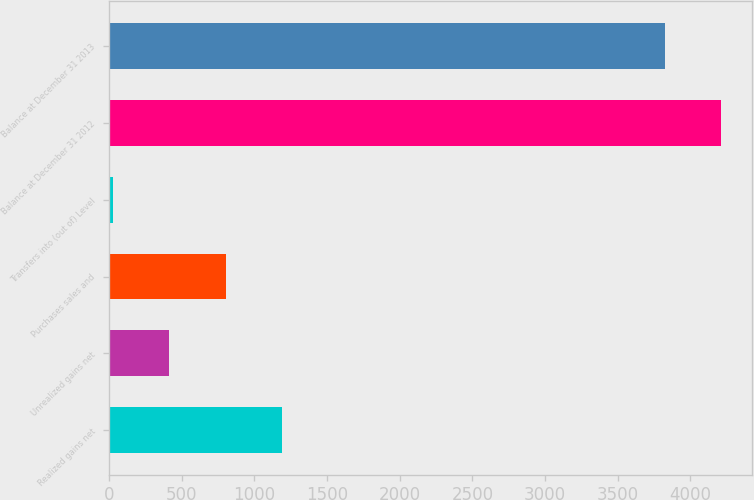Convert chart. <chart><loc_0><loc_0><loc_500><loc_500><bar_chart><fcel>Realized gains net<fcel>Unrealized gains net<fcel>Purchases sales and<fcel>Transfers into (out of) Level<fcel>Balance at December 31 2012<fcel>Balance at December 31 2013<nl><fcel>1190.2<fcel>415.4<fcel>802.8<fcel>28<fcel>4210.4<fcel>3823<nl></chart> 